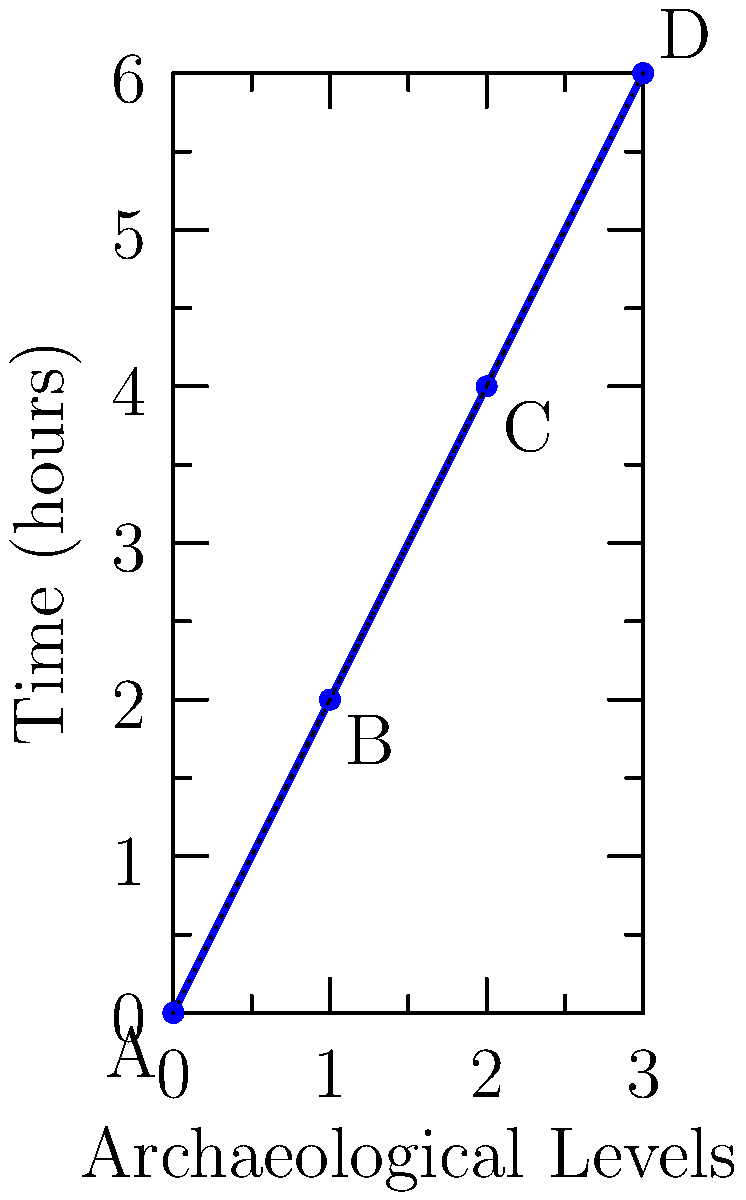As a staff member assisting elders in exploring a multi-level archaeological site, you need to optimize the exploration route. The graph shows the time required to explore different levels of the site. What is the minimum time needed to explore all levels if you can skip intermediate levels but must start at level A and end at level D? To find the minimum time to explore all levels, we need to consider all possible paths from A to D:

1. Path A-B-C-D:
   Time = 2 + 2 + 2 = 6 hours

2. Path A-B-D:
   Time = 2 + 4 = 6 hours

3. Path A-C-D:
   Time = 4 + 2 = 6 hours

4. Path A-D (direct):
   Time = 6 hours

Step-by-step analysis:
1. All paths that involve visiting every level (A-B-C-D) or skipping one level (A-B-D and A-C-D) result in a total time of 6 hours.
2. The direct path from A to D also takes 6 hours.
3. There is no path that results in a shorter time than 6 hours.

Therefore, the minimum time needed to explore all levels, starting at A and ending at D, is 6 hours. This can be achieved through any of the paths mentioned above.
Answer: 6 hours 